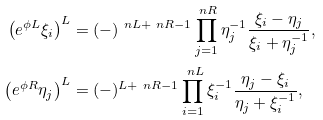<formula> <loc_0><loc_0><loc_500><loc_500>\left ( e ^ { \phi L } \xi _ { i } \right ) ^ { L } & = ( - ) ^ { \ n L + \ n R - 1 } \prod _ { j = 1 } ^ { \ n R } \eta _ { j } ^ { - 1 } \frac { \xi _ { i } - \eta _ { j } } { \xi _ { i } + \eta _ { j } ^ { - 1 } } , \\ \left ( e ^ { \phi R } \eta _ { j } \right ) ^ { L } & = ( - ) ^ { L + \ n R - 1 } \prod _ { i = 1 } ^ { \ n L } \xi _ { i } ^ { - 1 } \frac { \eta _ { j } - \xi _ { i } } { \eta _ { j } + \xi _ { i } ^ { - 1 } } ,</formula> 